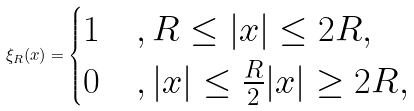Convert formula to latex. <formula><loc_0><loc_0><loc_500><loc_500>\xi _ { R } ( x ) = \begin{cases} 1 & , R \leq | x | \leq 2 R , \\ 0 & , | x | \leq \frac { R } { 2 } | x | \geq 2 R , \end{cases}</formula> 